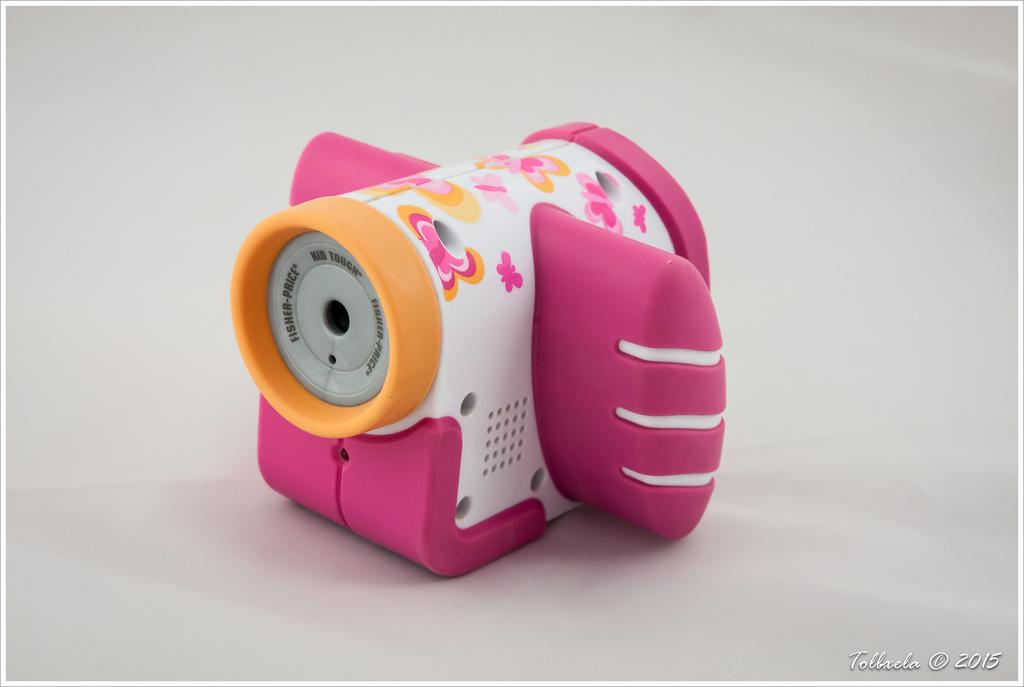What type of object is the main subject of the image? There is a baby toy in the image. What can be seen in the background of the image? The background of the image features a plane. Is there any text present in the image? Yes, there is some text at the right bottom of the image. How does the toothpaste help the baby toy in the image? There is no toothpaste present in the image, so it cannot help the baby toy. 